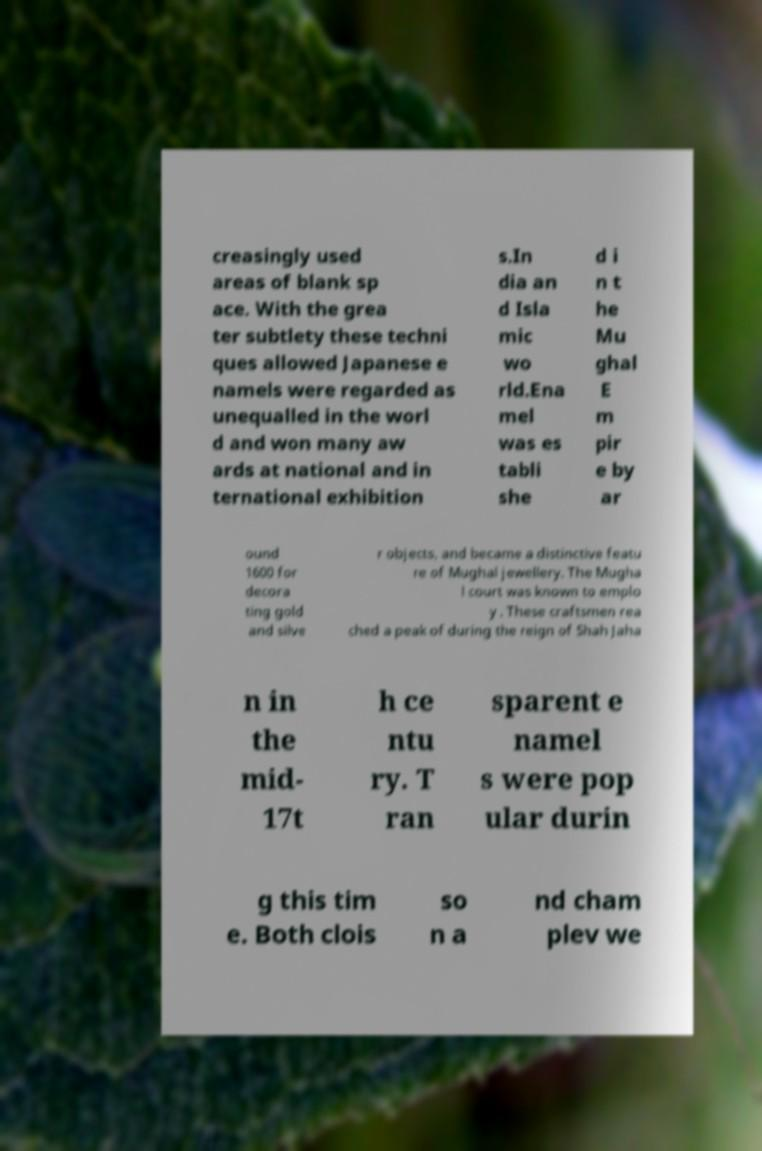There's text embedded in this image that I need extracted. Can you transcribe it verbatim? creasingly used areas of blank sp ace. With the grea ter subtlety these techni ques allowed Japanese e namels were regarded as unequalled in the worl d and won many aw ards at national and in ternational exhibition s.In dia an d Isla mic wo rld.Ena mel was es tabli she d i n t he Mu ghal E m pir e by ar ound 1600 for decora ting gold and silve r objects, and became a distinctive featu re of Mughal jewellery. The Mugha l court was known to emplo y . These craftsmen rea ched a peak of during the reign of Shah Jaha n in the mid- 17t h ce ntu ry. T ran sparent e namel s were pop ular durin g this tim e. Both clois so n a nd cham plev we 